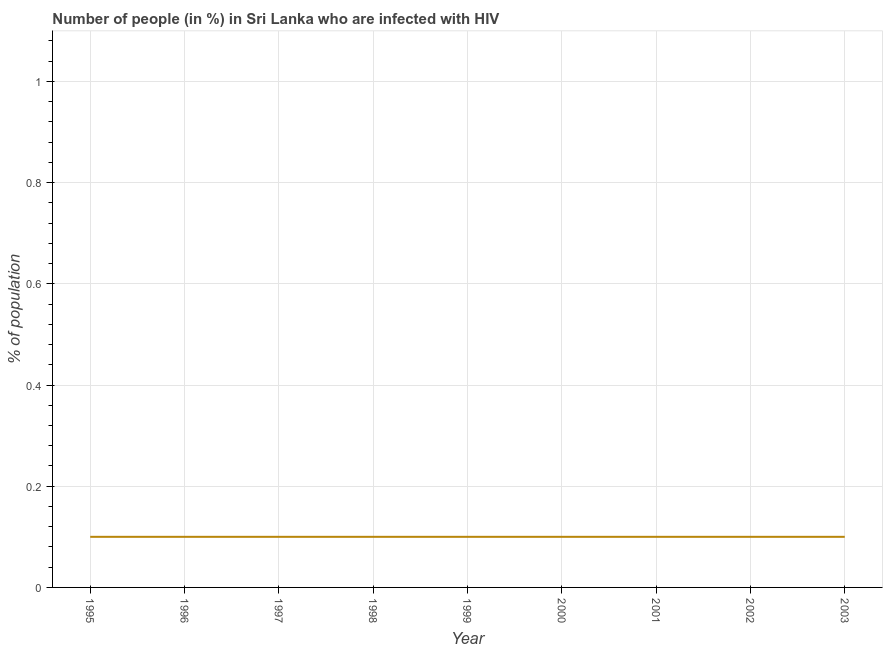What is the number of people infected with hiv in 1995?
Ensure brevity in your answer.  0.1. Across all years, what is the maximum number of people infected with hiv?
Give a very brief answer. 0.1. In which year was the number of people infected with hiv maximum?
Your answer should be compact. 1995. What is the sum of the number of people infected with hiv?
Your answer should be compact. 0.9. What is the average number of people infected with hiv per year?
Your answer should be very brief. 0.1. What is the ratio of the number of people infected with hiv in 2000 to that in 2001?
Make the answer very short. 1. Is the difference between the number of people infected with hiv in 1995 and 1999 greater than the difference between any two years?
Offer a very short reply. Yes. What is the difference between the highest and the second highest number of people infected with hiv?
Provide a short and direct response. 0. Is the sum of the number of people infected with hiv in 1998 and 2002 greater than the maximum number of people infected with hiv across all years?
Your response must be concise. Yes. In how many years, is the number of people infected with hiv greater than the average number of people infected with hiv taken over all years?
Offer a terse response. 0. Does the number of people infected with hiv monotonically increase over the years?
Offer a terse response. No. How many lines are there?
Offer a terse response. 1. How many years are there in the graph?
Offer a very short reply. 9. What is the difference between two consecutive major ticks on the Y-axis?
Keep it short and to the point. 0.2. Are the values on the major ticks of Y-axis written in scientific E-notation?
Give a very brief answer. No. Does the graph contain grids?
Your response must be concise. Yes. What is the title of the graph?
Your response must be concise. Number of people (in %) in Sri Lanka who are infected with HIV. What is the label or title of the X-axis?
Ensure brevity in your answer.  Year. What is the label or title of the Y-axis?
Keep it short and to the point. % of population. What is the % of population in 1995?
Provide a succinct answer. 0.1. What is the % of population in 1996?
Your answer should be very brief. 0.1. What is the % of population of 2000?
Your response must be concise. 0.1. What is the difference between the % of population in 1995 and 1996?
Offer a terse response. 0. What is the difference between the % of population in 1995 and 1997?
Your answer should be very brief. 0. What is the difference between the % of population in 1995 and 1998?
Keep it short and to the point. 0. What is the difference between the % of population in 1995 and 1999?
Keep it short and to the point. 0. What is the difference between the % of population in 1995 and 2000?
Offer a very short reply. 0. What is the difference between the % of population in 1995 and 2001?
Give a very brief answer. 0. What is the difference between the % of population in 1995 and 2003?
Offer a very short reply. 0. What is the difference between the % of population in 1996 and 1997?
Your response must be concise. 0. What is the difference between the % of population in 1996 and 1998?
Your response must be concise. 0. What is the difference between the % of population in 1996 and 2000?
Your response must be concise. 0. What is the difference between the % of population in 1996 and 2001?
Offer a terse response. 0. What is the difference between the % of population in 1996 and 2002?
Offer a terse response. 0. What is the difference between the % of population in 1997 and 1999?
Offer a very short reply. 0. What is the difference between the % of population in 1997 and 2002?
Your response must be concise. 0. What is the difference between the % of population in 1999 and 2001?
Offer a terse response. 0. What is the difference between the % of population in 1999 and 2002?
Provide a short and direct response. 0. What is the difference between the % of population in 2000 and 2001?
Your answer should be compact. 0. What is the difference between the % of population in 2000 and 2003?
Offer a very short reply. 0. What is the difference between the % of population in 2001 and 2002?
Give a very brief answer. 0. What is the difference between the % of population in 2002 and 2003?
Keep it short and to the point. 0. What is the ratio of the % of population in 1995 to that in 1999?
Offer a very short reply. 1. What is the ratio of the % of population in 1995 to that in 2003?
Your answer should be very brief. 1. What is the ratio of the % of population in 1996 to that in 1997?
Keep it short and to the point. 1. What is the ratio of the % of population in 1997 to that in 2000?
Ensure brevity in your answer.  1. What is the ratio of the % of population in 1997 to that in 2003?
Offer a terse response. 1. What is the ratio of the % of population in 1998 to that in 1999?
Keep it short and to the point. 1. What is the ratio of the % of population in 1998 to that in 2000?
Ensure brevity in your answer.  1. What is the ratio of the % of population in 1998 to that in 2001?
Provide a succinct answer. 1. What is the ratio of the % of population in 1998 to that in 2003?
Your answer should be very brief. 1. What is the ratio of the % of population in 1999 to that in 2001?
Provide a short and direct response. 1. What is the ratio of the % of population in 1999 to that in 2002?
Ensure brevity in your answer.  1. What is the ratio of the % of population in 2000 to that in 2003?
Keep it short and to the point. 1. What is the ratio of the % of population in 2001 to that in 2002?
Offer a terse response. 1. 